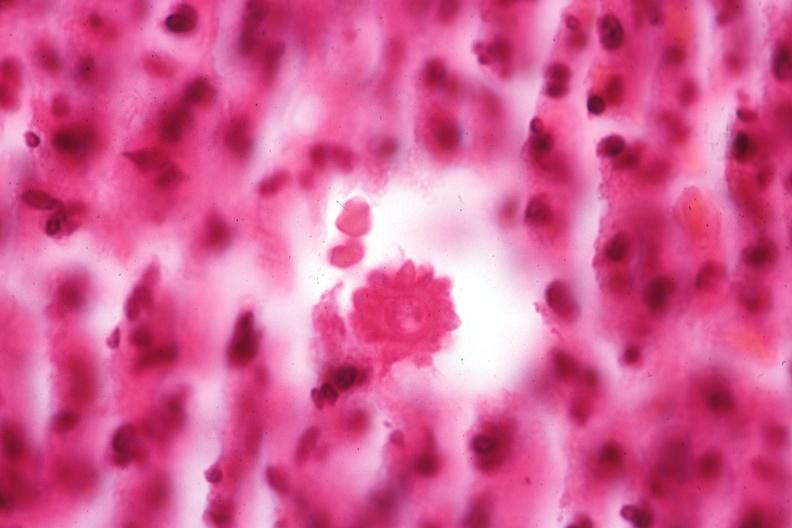does nuclear change show oil immersion organism very well shown?
Answer the question using a single word or phrase. No 